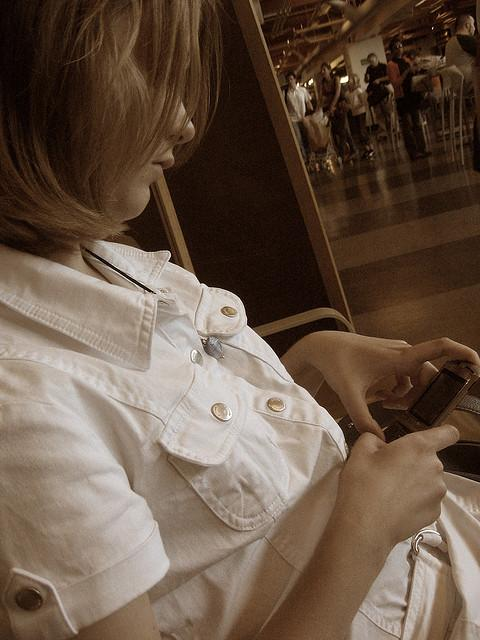What are the people lining up for? food 